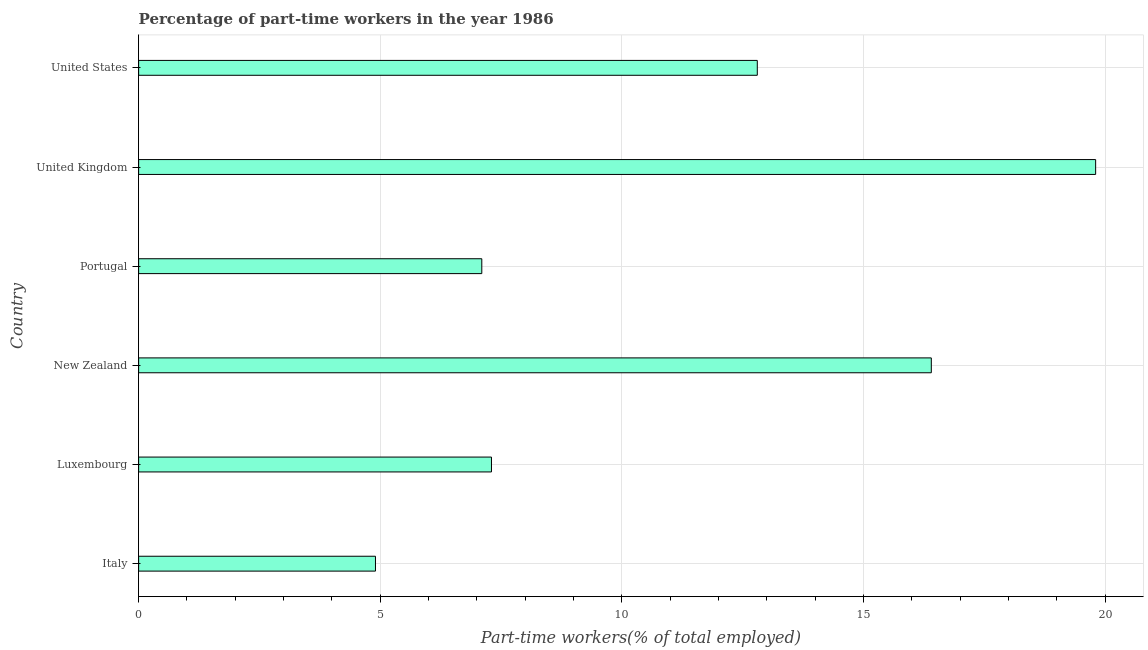What is the title of the graph?
Give a very brief answer. Percentage of part-time workers in the year 1986. What is the label or title of the X-axis?
Offer a terse response. Part-time workers(% of total employed). What is the label or title of the Y-axis?
Make the answer very short. Country. What is the percentage of part-time workers in Luxembourg?
Offer a very short reply. 7.3. Across all countries, what is the maximum percentage of part-time workers?
Keep it short and to the point. 19.8. Across all countries, what is the minimum percentage of part-time workers?
Provide a short and direct response. 4.9. What is the sum of the percentage of part-time workers?
Keep it short and to the point. 68.3. What is the difference between the percentage of part-time workers in Italy and United Kingdom?
Offer a terse response. -14.9. What is the average percentage of part-time workers per country?
Offer a terse response. 11.38. What is the median percentage of part-time workers?
Give a very brief answer. 10.05. In how many countries, is the percentage of part-time workers greater than 8 %?
Your answer should be very brief. 3. What is the ratio of the percentage of part-time workers in Luxembourg to that in United States?
Ensure brevity in your answer.  0.57. Is the percentage of part-time workers in Italy less than that in United Kingdom?
Provide a succinct answer. Yes. What is the difference between the highest and the second highest percentage of part-time workers?
Make the answer very short. 3.4. Is the sum of the percentage of part-time workers in Italy and United Kingdom greater than the maximum percentage of part-time workers across all countries?
Your response must be concise. Yes. What is the difference between the highest and the lowest percentage of part-time workers?
Give a very brief answer. 14.9. In how many countries, is the percentage of part-time workers greater than the average percentage of part-time workers taken over all countries?
Give a very brief answer. 3. How many bars are there?
Your answer should be very brief. 6. Are all the bars in the graph horizontal?
Your answer should be compact. Yes. How many countries are there in the graph?
Your answer should be compact. 6. What is the difference between two consecutive major ticks on the X-axis?
Provide a short and direct response. 5. Are the values on the major ticks of X-axis written in scientific E-notation?
Ensure brevity in your answer.  No. What is the Part-time workers(% of total employed) of Italy?
Offer a very short reply. 4.9. What is the Part-time workers(% of total employed) in Luxembourg?
Give a very brief answer. 7.3. What is the Part-time workers(% of total employed) of New Zealand?
Give a very brief answer. 16.4. What is the Part-time workers(% of total employed) in Portugal?
Provide a succinct answer. 7.1. What is the Part-time workers(% of total employed) of United Kingdom?
Keep it short and to the point. 19.8. What is the Part-time workers(% of total employed) in United States?
Provide a succinct answer. 12.8. What is the difference between the Part-time workers(% of total employed) in Italy and Portugal?
Offer a terse response. -2.2. What is the difference between the Part-time workers(% of total employed) in Italy and United Kingdom?
Your answer should be compact. -14.9. What is the difference between the Part-time workers(% of total employed) in Italy and United States?
Offer a terse response. -7.9. What is the difference between the Part-time workers(% of total employed) in Luxembourg and New Zealand?
Give a very brief answer. -9.1. What is the difference between the Part-time workers(% of total employed) in Luxembourg and United Kingdom?
Ensure brevity in your answer.  -12.5. What is the difference between the Part-time workers(% of total employed) in Luxembourg and United States?
Make the answer very short. -5.5. What is the difference between the Part-time workers(% of total employed) in New Zealand and Portugal?
Offer a terse response. 9.3. What is the difference between the Part-time workers(% of total employed) in New Zealand and United Kingdom?
Provide a short and direct response. -3.4. What is the difference between the Part-time workers(% of total employed) in Portugal and United Kingdom?
Give a very brief answer. -12.7. What is the difference between the Part-time workers(% of total employed) in United Kingdom and United States?
Provide a succinct answer. 7. What is the ratio of the Part-time workers(% of total employed) in Italy to that in Luxembourg?
Provide a succinct answer. 0.67. What is the ratio of the Part-time workers(% of total employed) in Italy to that in New Zealand?
Provide a short and direct response. 0.3. What is the ratio of the Part-time workers(% of total employed) in Italy to that in Portugal?
Offer a terse response. 0.69. What is the ratio of the Part-time workers(% of total employed) in Italy to that in United Kingdom?
Offer a very short reply. 0.25. What is the ratio of the Part-time workers(% of total employed) in Italy to that in United States?
Offer a very short reply. 0.38. What is the ratio of the Part-time workers(% of total employed) in Luxembourg to that in New Zealand?
Make the answer very short. 0.45. What is the ratio of the Part-time workers(% of total employed) in Luxembourg to that in Portugal?
Give a very brief answer. 1.03. What is the ratio of the Part-time workers(% of total employed) in Luxembourg to that in United Kingdom?
Offer a very short reply. 0.37. What is the ratio of the Part-time workers(% of total employed) in Luxembourg to that in United States?
Offer a very short reply. 0.57. What is the ratio of the Part-time workers(% of total employed) in New Zealand to that in Portugal?
Offer a very short reply. 2.31. What is the ratio of the Part-time workers(% of total employed) in New Zealand to that in United Kingdom?
Your response must be concise. 0.83. What is the ratio of the Part-time workers(% of total employed) in New Zealand to that in United States?
Offer a very short reply. 1.28. What is the ratio of the Part-time workers(% of total employed) in Portugal to that in United Kingdom?
Provide a short and direct response. 0.36. What is the ratio of the Part-time workers(% of total employed) in Portugal to that in United States?
Your response must be concise. 0.56. What is the ratio of the Part-time workers(% of total employed) in United Kingdom to that in United States?
Ensure brevity in your answer.  1.55. 